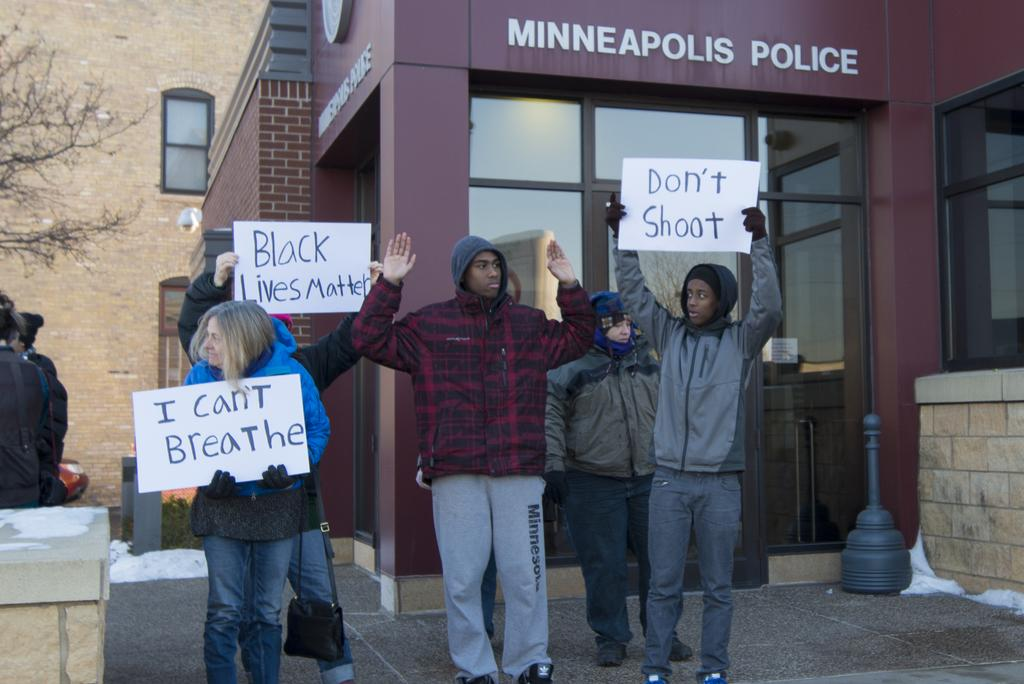What are the people in the image doing? The people in the image are standing and holding a poster. What can be seen on the poster? The poster has text on it. What is visible in the background of the image? There is a building and a tree in the background of the image. What type of throat lozenges are being handed out at night in the image? There is no mention of throat lozenges or nighttime in the image; it features people holding a poster with text on it, and a building and a tree in the background. 